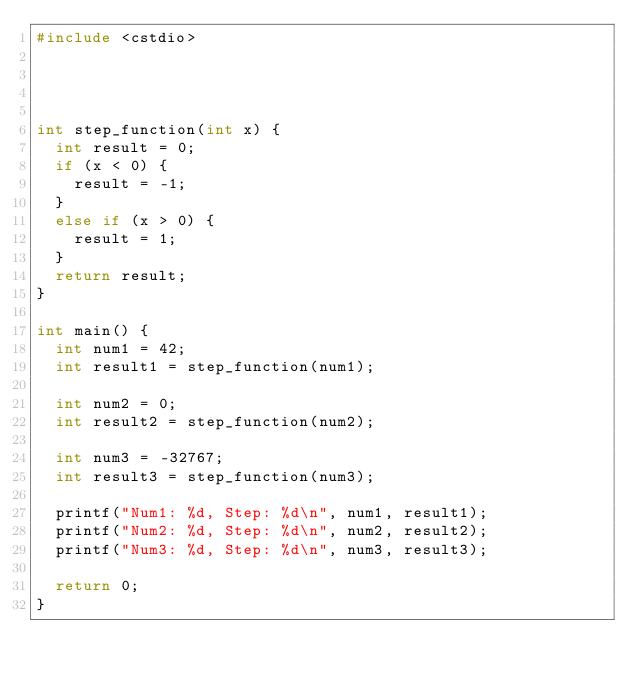<code> <loc_0><loc_0><loc_500><loc_500><_C++_>#include <cstdio>




int step_function(int x) {
	int result = 0;
	if (x < 0) {
		result = -1;
	}
	else if (x > 0) {
		result = 1;
	}
	return result;
} 

int main() {
	int num1 = 42;
	int result1 = step_function(num1);

	int num2 = 0;
	int result2 = step_function(num2);

	int num3 = -32767;
	int result3 = step_function(num3);

	printf("Num1: %d, Step: %d\n", num1, result1);
	printf("Num2: %d, Step: %d\n", num2, result2);
	printf("Num3: %d, Step: %d\n", num3, result3);
	
	return 0;
}

</code> 